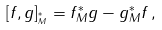<formula> <loc_0><loc_0><loc_500><loc_500>[ f , g ] _ { ^ { * } _ { M } } = f ^ { * } _ { M } g - g ^ { * } _ { M } f \, ,</formula> 